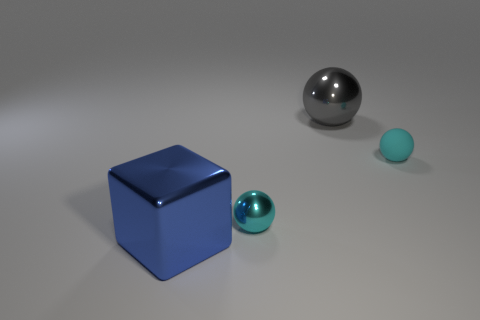Add 1 small brown rubber objects. How many objects exist? 5 Subtract all blocks. How many objects are left? 3 Subtract all big cubes. Subtract all large blue objects. How many objects are left? 2 Add 3 cyan matte things. How many cyan matte things are left? 4 Add 4 metal objects. How many metal objects exist? 7 Subtract 0 gray cylinders. How many objects are left? 4 